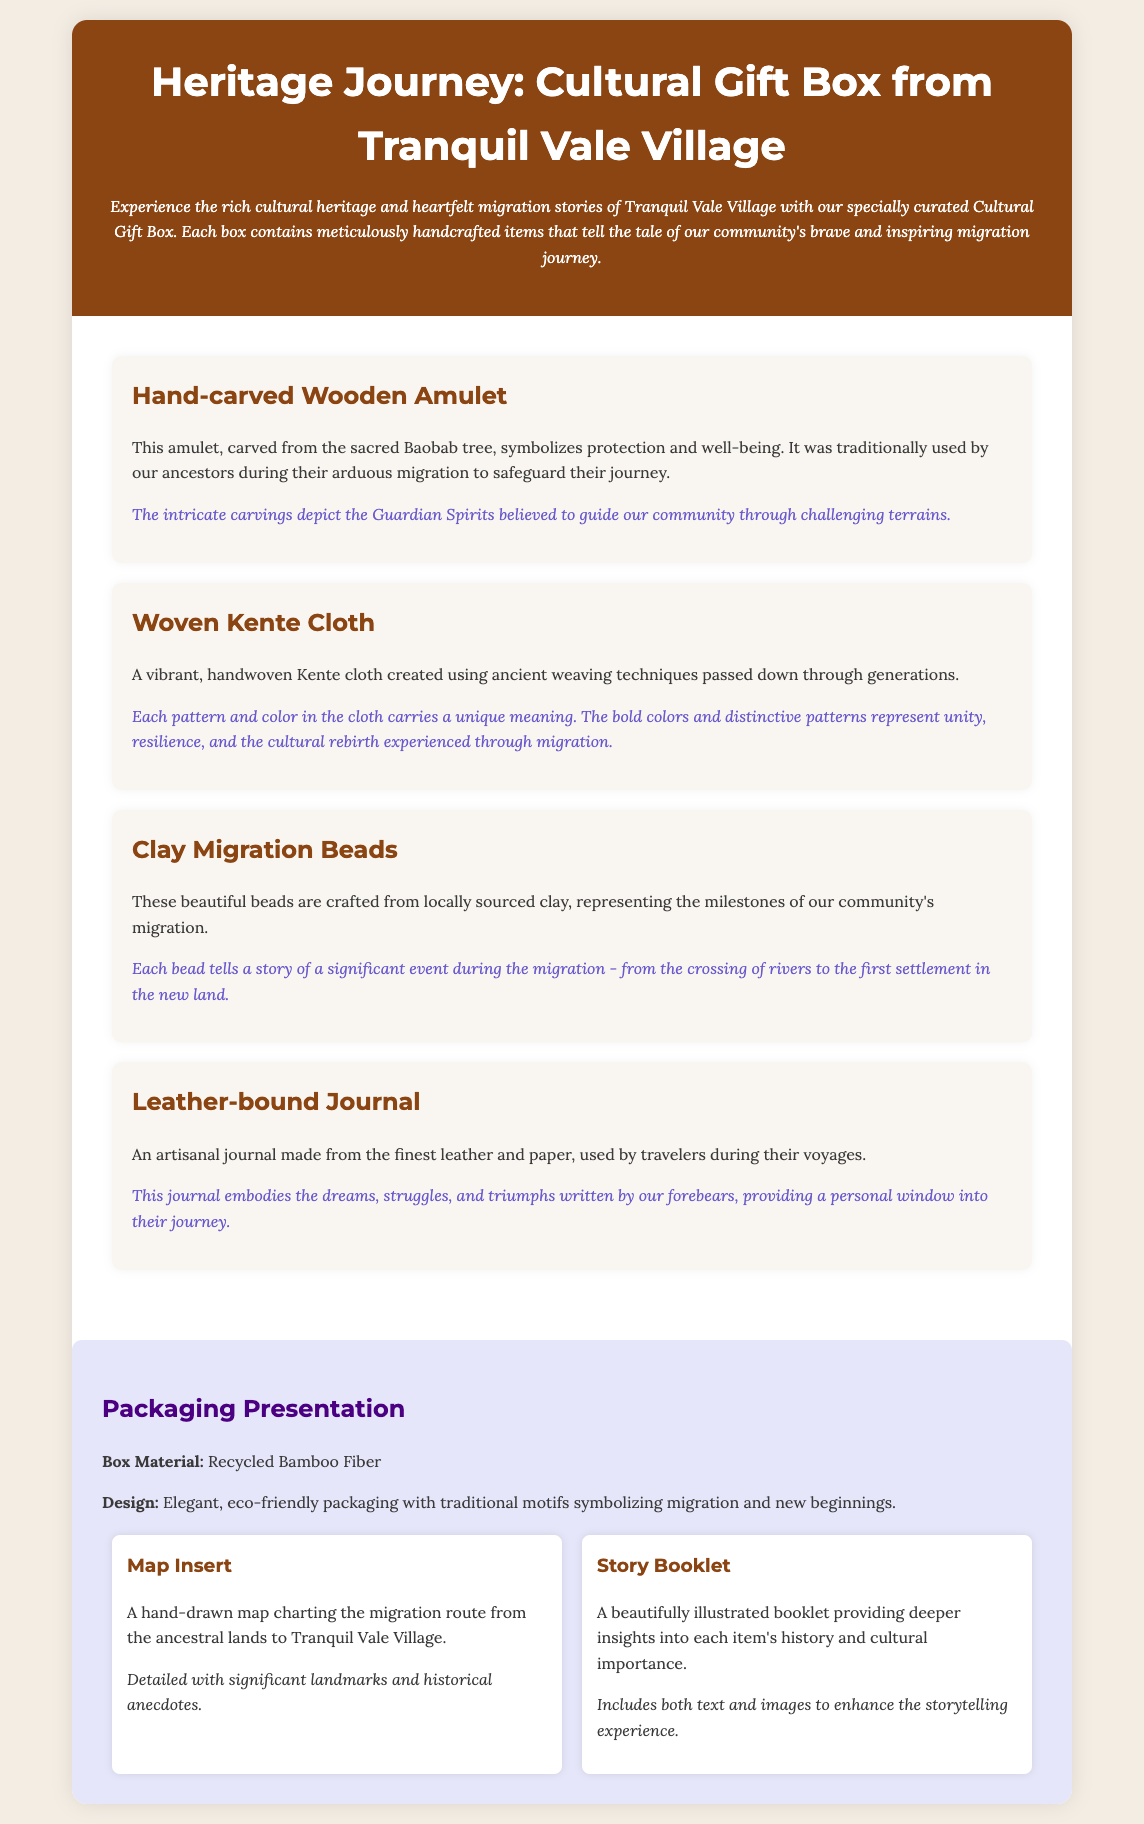What is the title of the product? The title of the product is presented prominently at the top of the document.
Answer: Heritage Journey: Cultural Gift Box from Tranquil Vale Village What material is the box made of? The material of the box is specified in the packaging presentation section.
Answer: Recycled Bamboo Fiber What type of cloth is included in the gift box? The document describes a specific item included in the Cultural Gift Box.
Answer: Woven Kente Cloth How many main items are described in the gift box? The number of items is determined by counting the items listed under the content section.
Answer: Four What does the leather-bound journal represent? The document explains the significance of the leather-bound journal in relation to the migration journey.
Answer: Dreams, struggles, and triumphs What do the clay migration beads represent? The significance of the clay migration beads relates to events during the community's migration.
Answer: Milestones of migration What is included in the Story Booklet? The document states what is featured in the Story Booklet under the additional elements section.
Answer: Insights into each item's history and cultural importance What does the hand-drawn map illustrate? The document specifies what the map insert is used for within the packaging.
Answer: Migration route from the ancestral lands to Tranquil Vale Village What color is used for the header background? The color is described in the CSS and can be inferred from the document's style.
Answer: Dark brown 